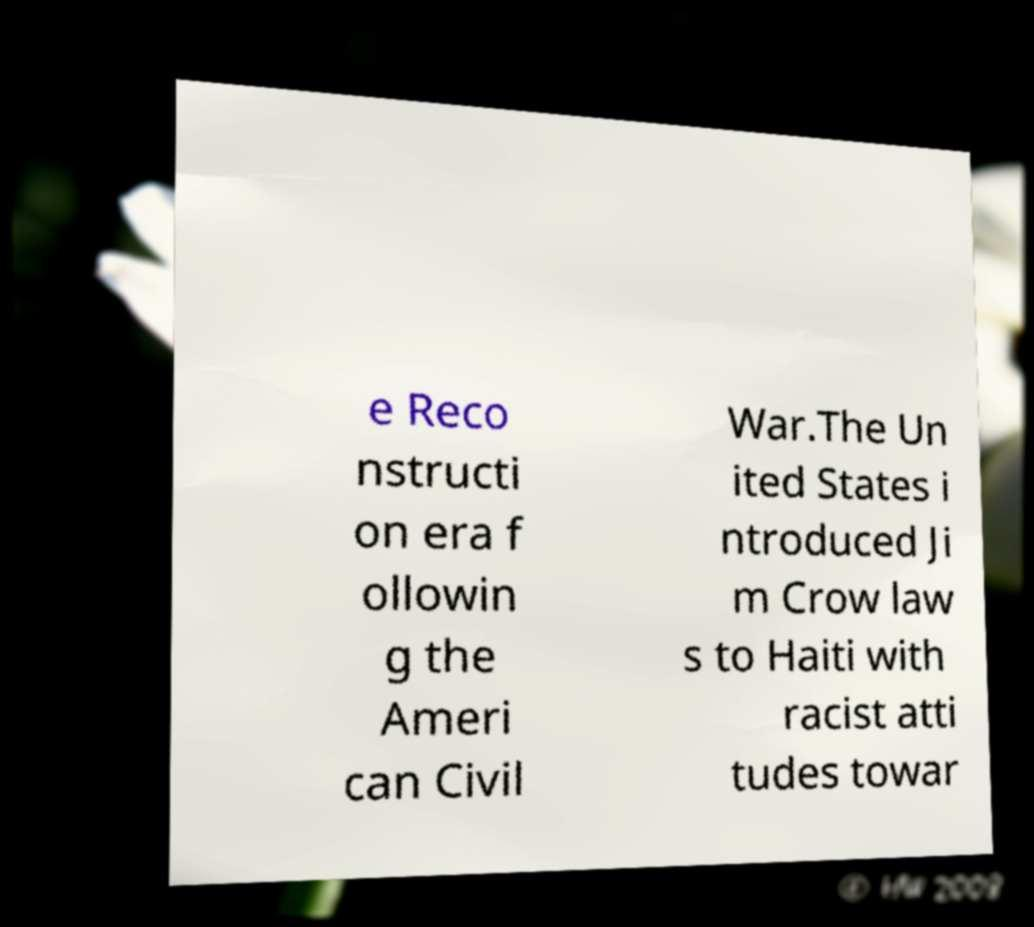I need the written content from this picture converted into text. Can you do that? e Reco nstructi on era f ollowin g the Ameri can Civil War.The Un ited States i ntroduced Ji m Crow law s to Haiti with racist atti tudes towar 